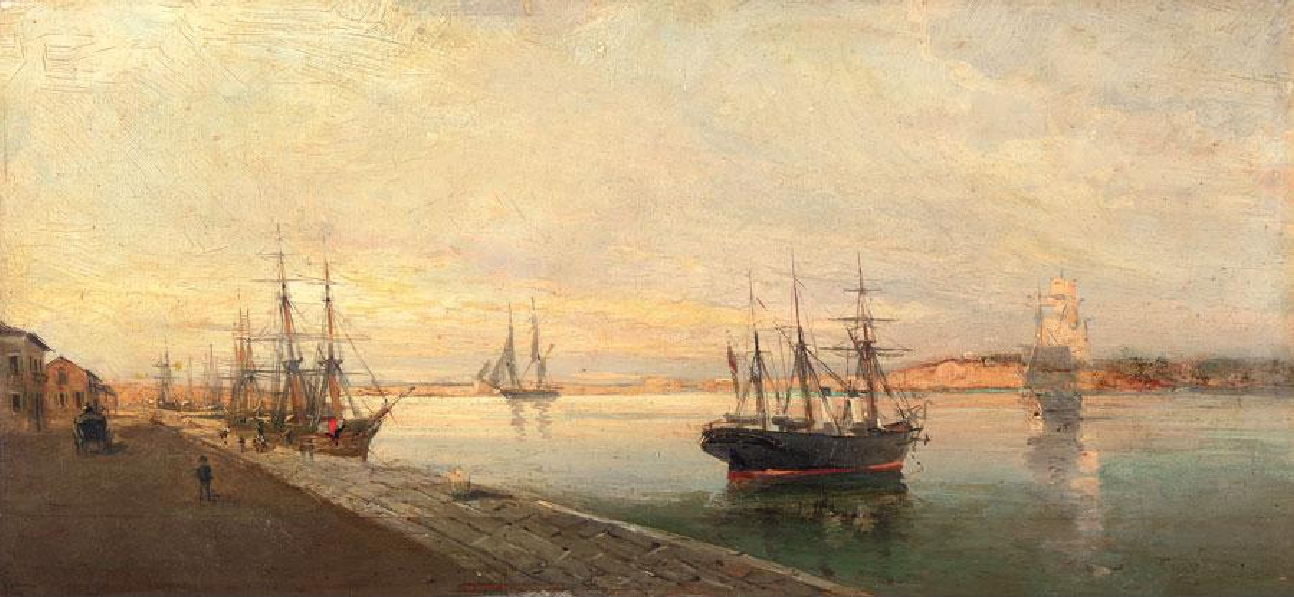Look at the characters in the painting. What can you infer about their lives and the role of the harbor in their community? The figures in the painting appear to engage in various activities, highlighting the harbor's role as a central hub of commerce and daily life for the community. Some individuals are occupied with tasks related to shipping – perhaps loading or unloading cargo, doing maintenance work on the boats, or preparing for a sea voyage. Others seem to be going about their day, taking a leisurely walk along the docks. This diversity of action suggests that the harbor was a place where work and social life intersected. The individuals depicted are likely a mixture of sailors, merchants, laborers, and townsfolk, each with their distinct relationship to the sea and its influence on their livelihoods. The harbor served not just as a gateway for goods and travel but also as a communal space that brought together people from all walks of life. 